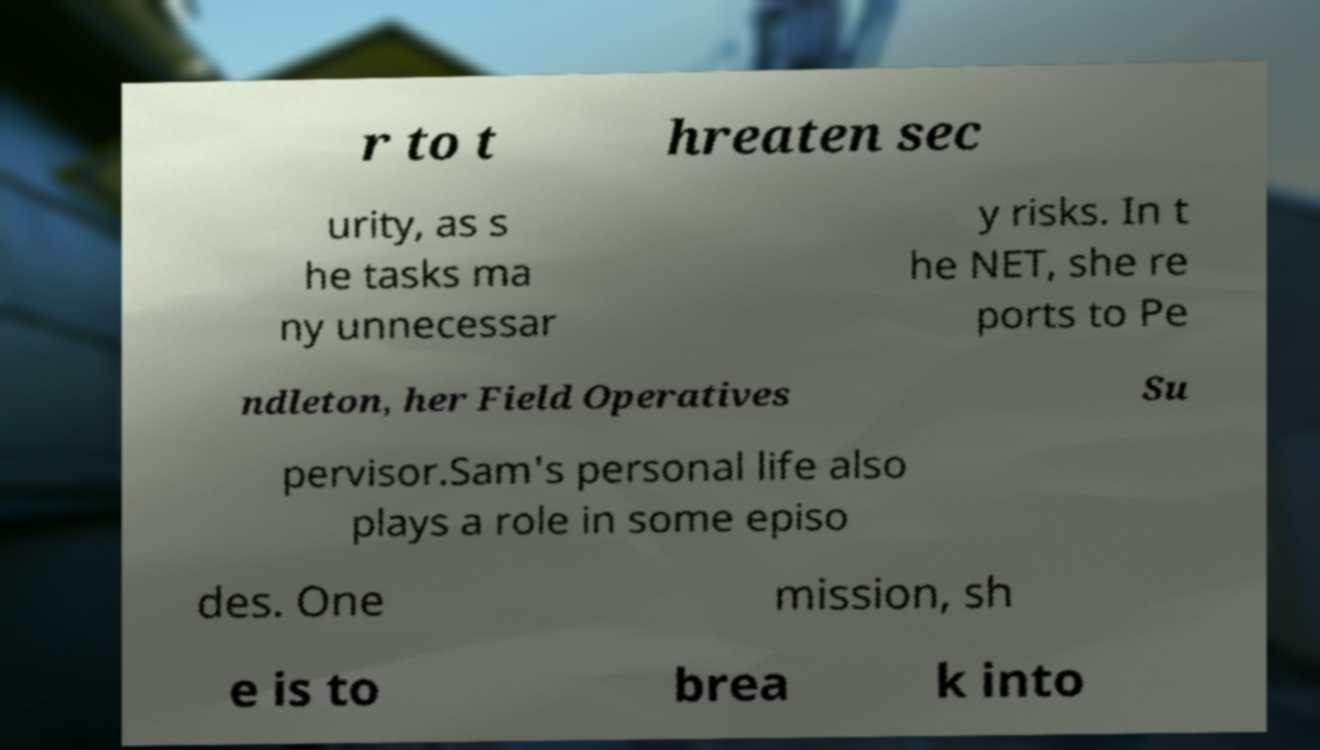Could you assist in decoding the text presented in this image and type it out clearly? r to t hreaten sec urity, as s he tasks ma ny unnecessar y risks. In t he NET, she re ports to Pe ndleton, her Field Operatives Su pervisor.Sam's personal life also plays a role in some episo des. One mission, sh e is to brea k into 